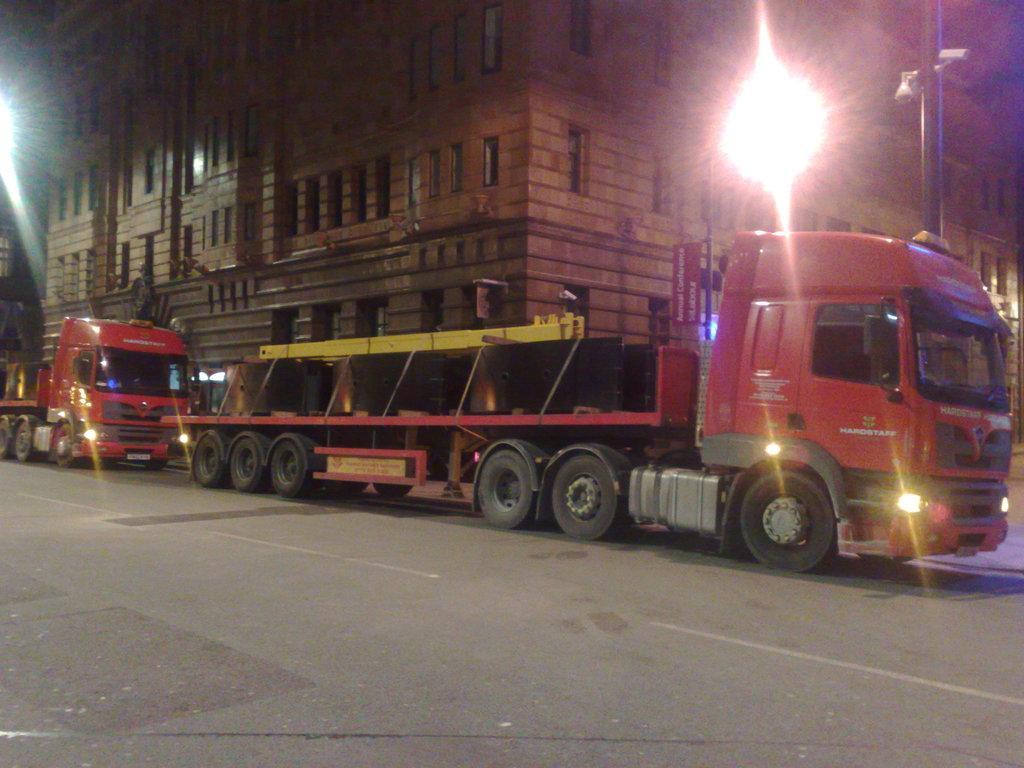Please provide a concise description of this image. In this picture we can see trucks on the road, in the background we can see a building, few lights and a pole. 